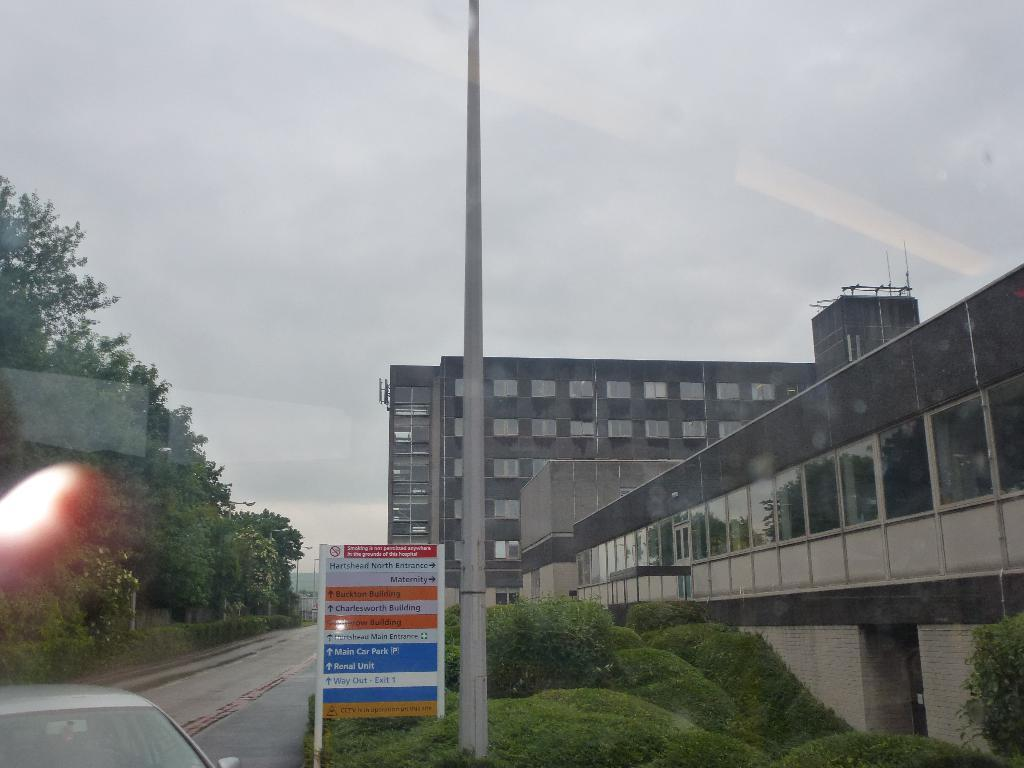What is the main subject in the image? There is a vehicle in the image. What else can be seen in the image besides the vehicle? There is a board visible in the image. What can be seen in the background of the image? In the background of the image, there are roads, buildings, trees, poles, and the sky. What type of door can be seen in the image? There is no door present in the image. Can you describe the mist in the image? There is no mist present in the image. 